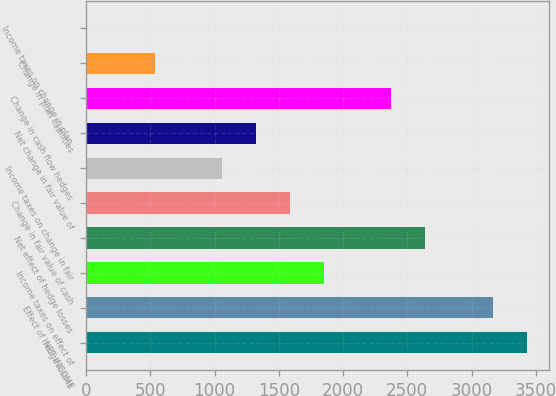Convert chart. <chart><loc_0><loc_0><loc_500><loc_500><bar_chart><fcel>NET INCOME<fcel>Effect of hedge losses<fcel>Income taxes on effect of<fcel>Net effect of hedge losses<fcel>Change in fair value of cash<fcel>Income taxes on change in fair<fcel>Net change in fair value of<fcel>Change in cash flow hedges<fcel>Change in plan liabilities<fcel>Income taxes on change in plan<nl><fcel>3428.6<fcel>3165.4<fcel>1849.4<fcel>2639<fcel>1586.2<fcel>1059.8<fcel>1323<fcel>2375.8<fcel>533.4<fcel>7<nl></chart> 